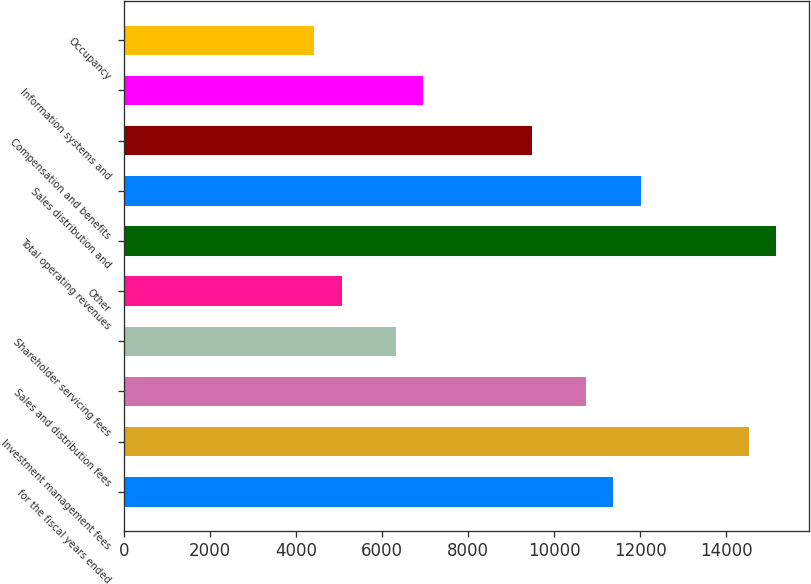Convert chart. <chart><loc_0><loc_0><loc_500><loc_500><bar_chart><fcel>for the fiscal years ended<fcel>Investment management fees<fcel>Sales and distribution fees<fcel>Shareholder servicing fees<fcel>Other<fcel>Total operating revenues<fcel>Sales distribution and<fcel>Compensation and benefits<fcel>Information systems and<fcel>Occupancy<nl><fcel>11373.2<fcel>14532.1<fcel>10741.5<fcel>6319.09<fcel>5055.55<fcel>15163.9<fcel>12005<fcel>9477.94<fcel>6950.86<fcel>4423.78<nl></chart> 